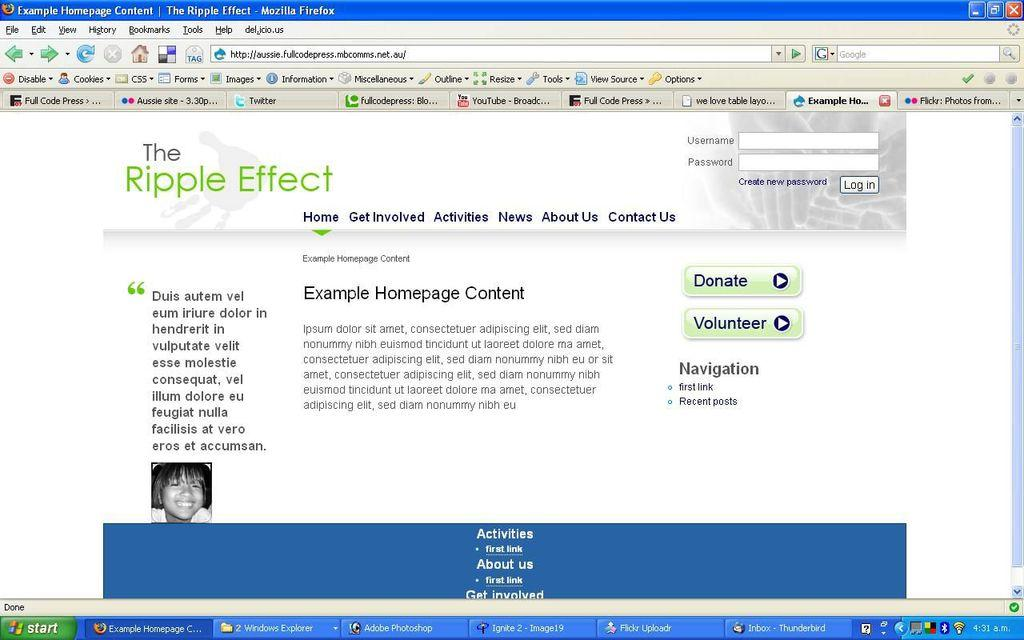<image>
Render a clear and concise summary of the photo. Computer screen that shows a picture of a woman and asks people to donate or volunteer. 